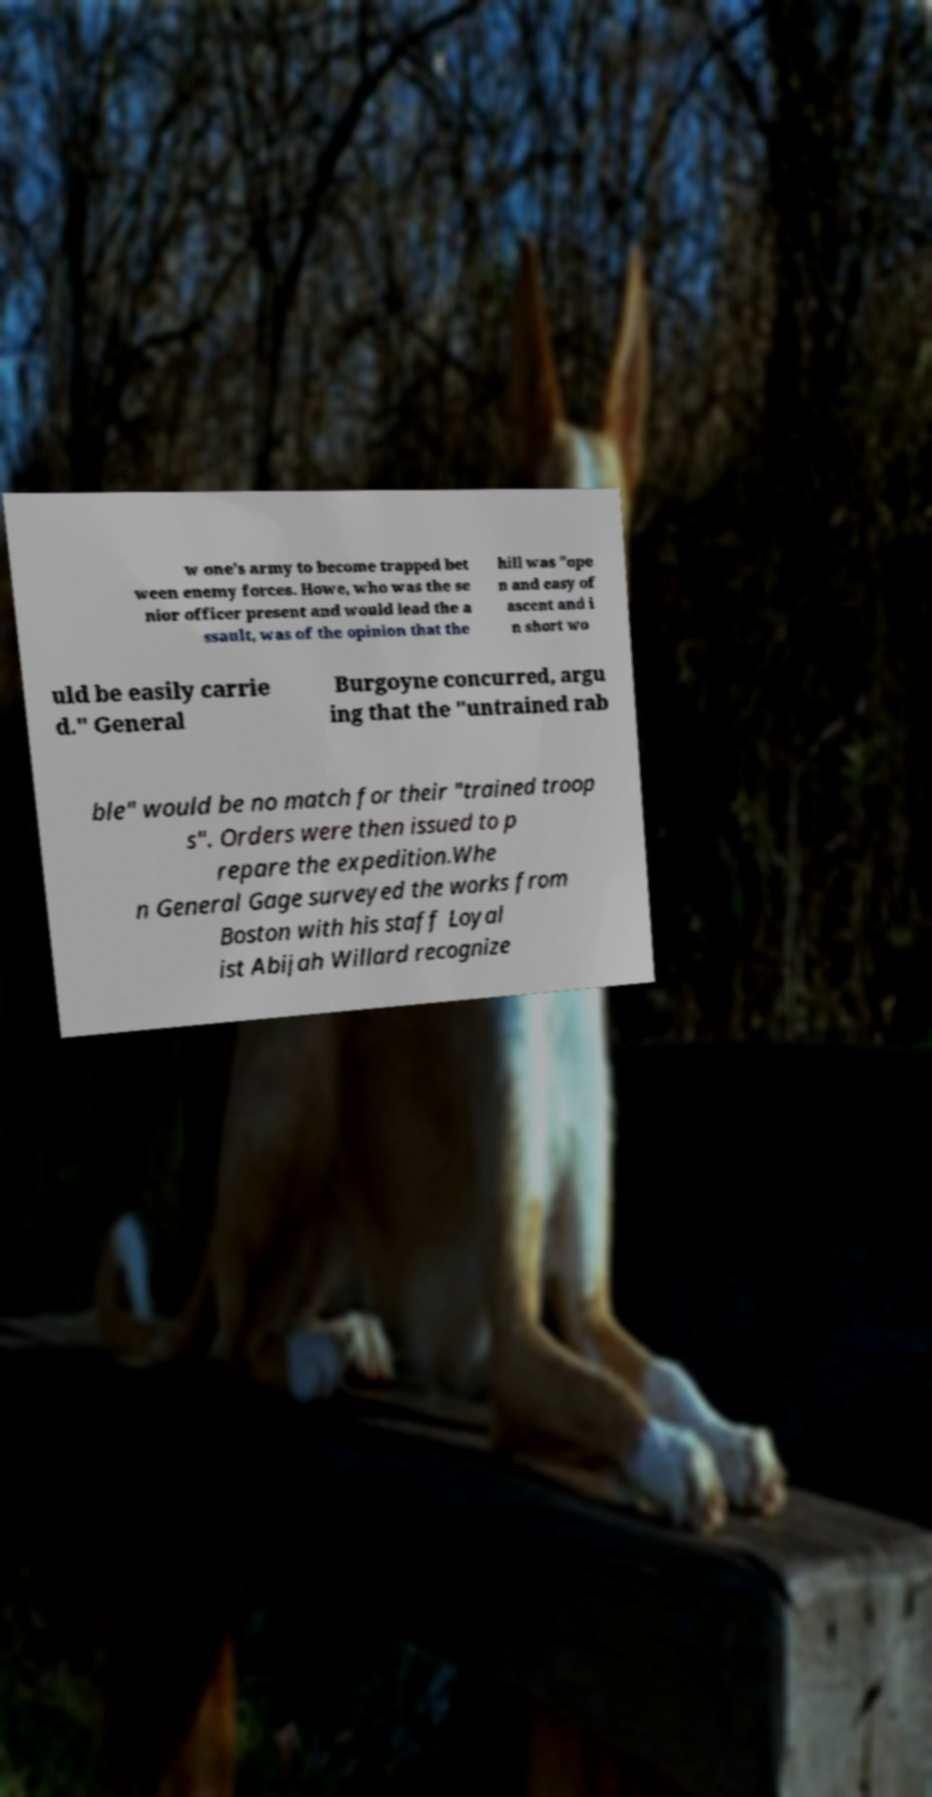Could you assist in decoding the text presented in this image and type it out clearly? w one's army to become trapped bet ween enemy forces. Howe, who was the se nior officer present and would lead the a ssault, was of the opinion that the hill was "ope n and easy of ascent and i n short wo uld be easily carrie d." General Burgoyne concurred, argu ing that the "untrained rab ble" would be no match for their "trained troop s". Orders were then issued to p repare the expedition.Whe n General Gage surveyed the works from Boston with his staff Loyal ist Abijah Willard recognize 